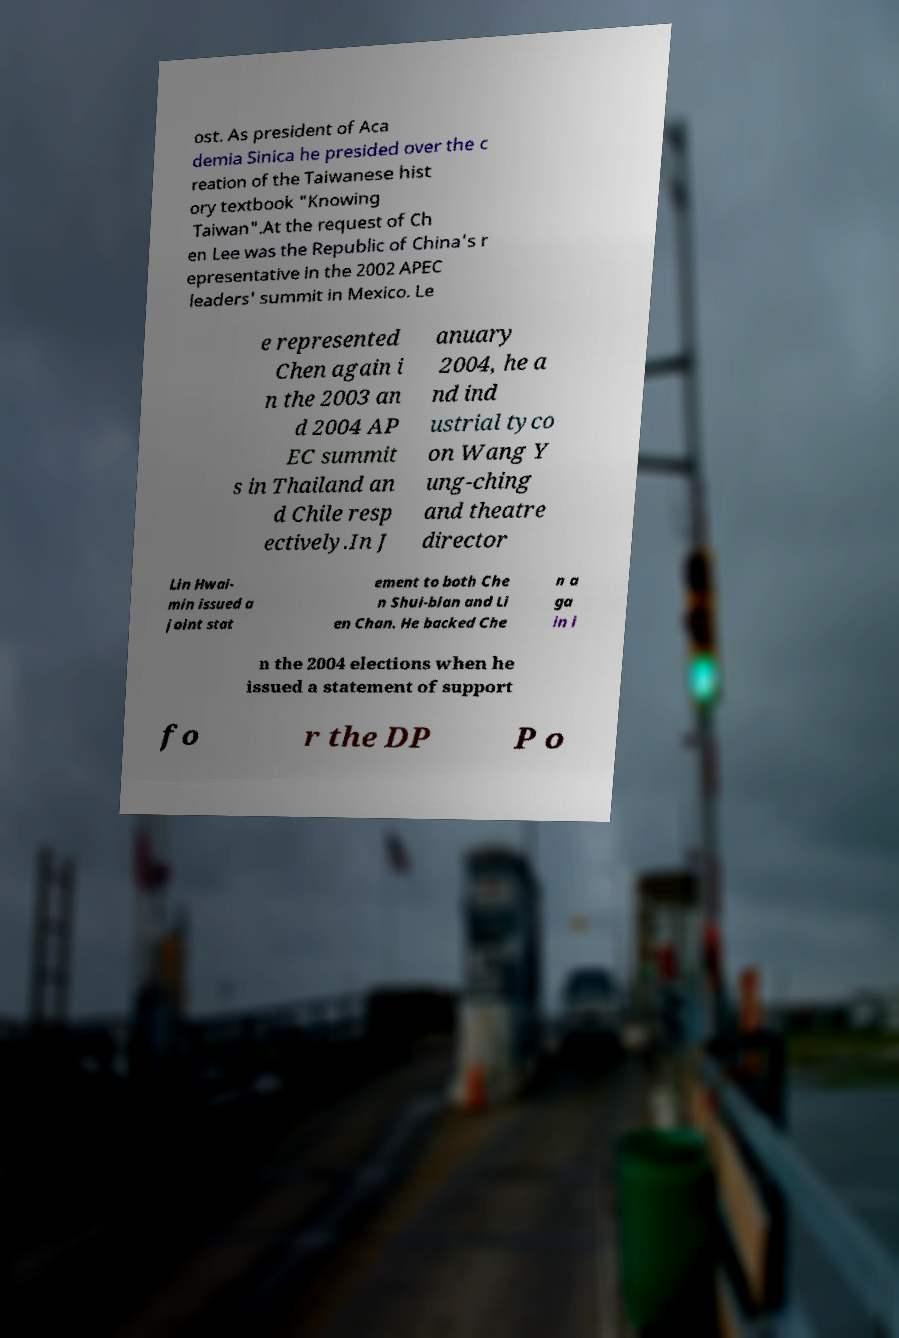Please identify and transcribe the text found in this image. ost. As president of Aca demia Sinica he presided over the c reation of the Taiwanese hist ory textbook "Knowing Taiwan".At the request of Ch en Lee was the Republic of China's r epresentative in the 2002 APEC leaders' summit in Mexico. Le e represented Chen again i n the 2003 an d 2004 AP EC summit s in Thailand an d Chile resp ectively.In J anuary 2004, he a nd ind ustrial tyco on Wang Y ung-ching and theatre director Lin Hwai- min issued a joint stat ement to both Che n Shui-bian and Li en Chan. He backed Che n a ga in i n the 2004 elections when he issued a statement of support fo r the DP P o 